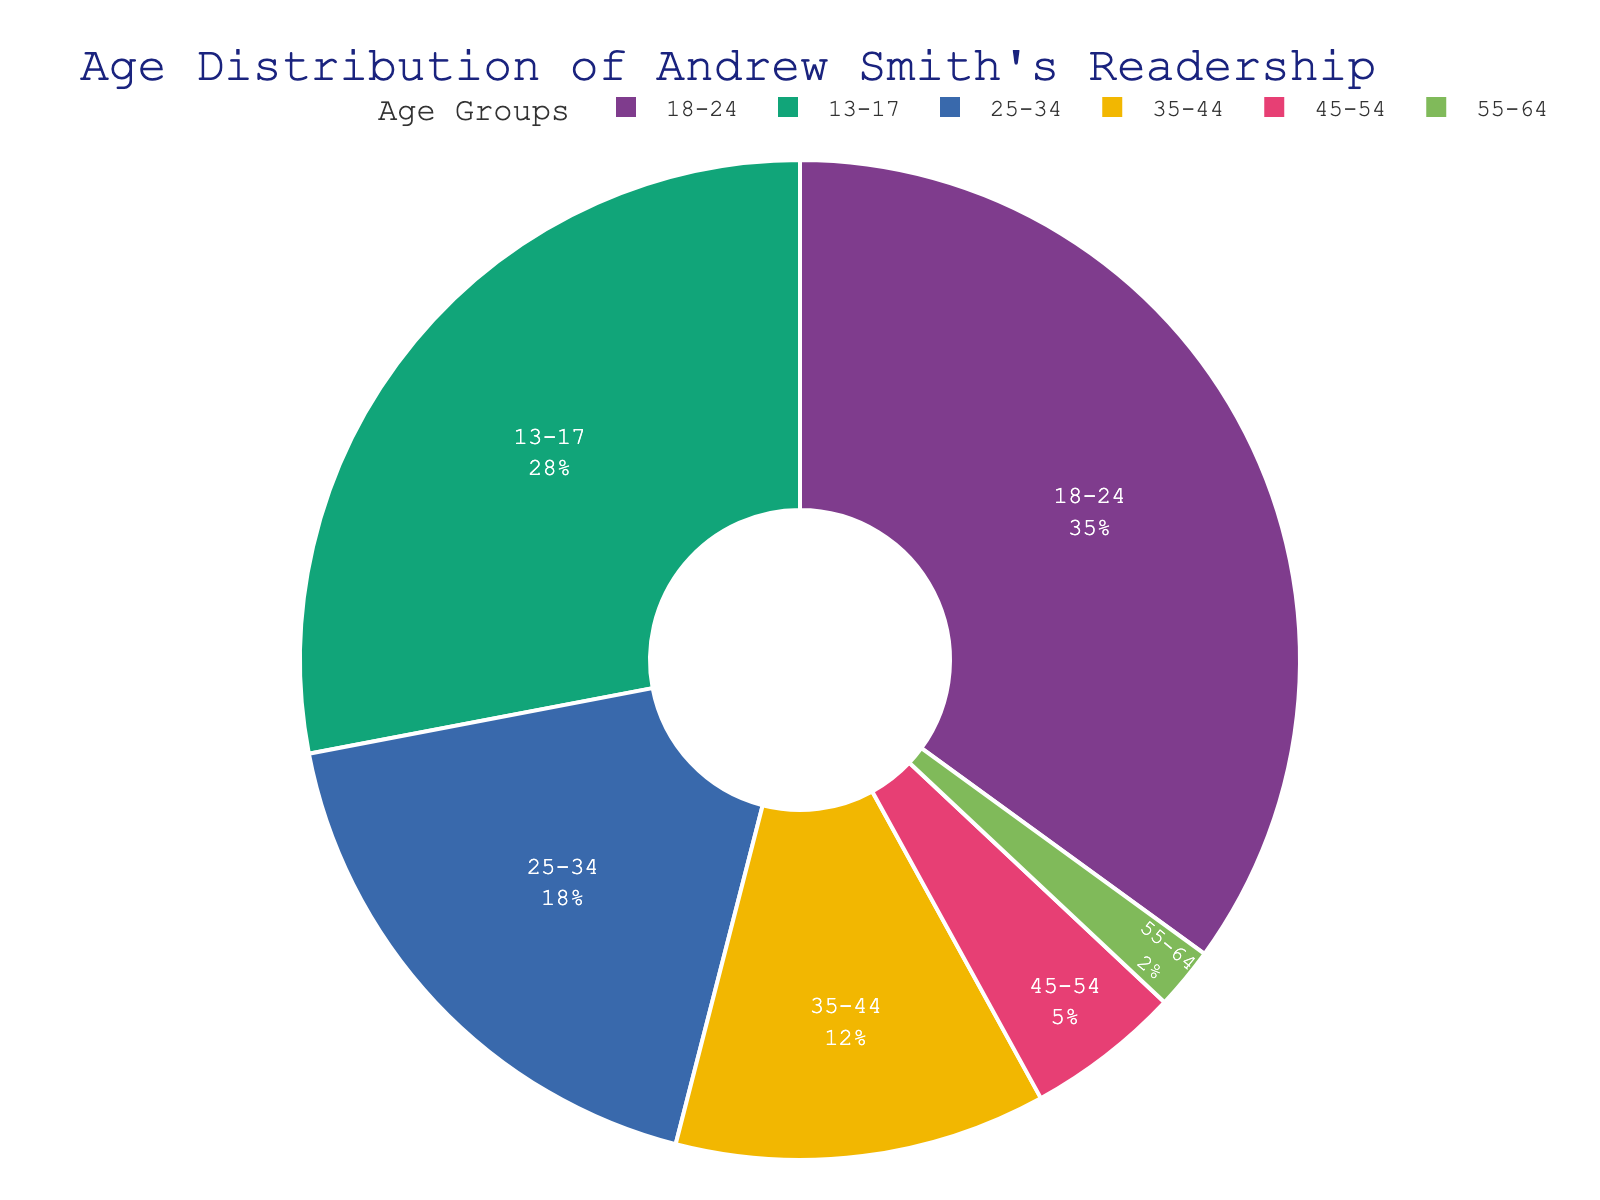Which age group has the highest percentage in Andrew Smith's readership? To determine the age group with the highest percentage, look at the section of the pie chart with the largest area or percentage label.
Answer: 18-24 What is the combined percentage of readers aged 35-44 and 45-54? Add the percentages of the two age groups: 12% (35-44) + 5% (45-54) = 17%.
Answer: 17% How does the proportion of readers aged 13-17 compare to those aged 25-34? Compare their percentages directly: 13-17 has 28% and 25-34 has 18%. 28% is greater than 18%.
Answer: 28% > 18% What is the difference in percentage between the 18-24 age group and the 55-64 age group? Subtract the percentage of the 55-64 group from the 18-24 group: 35% - 2% = 33%.
Answer: 33% Which age groups have a percentage less than 10%? Identify the age groups with percentages below 10%: 45-54 (5%) and 55-64 (2%).
Answer: 45-54, 55-64 What percentage of readers are aged 25-34 or older? Sum the percentages of all age groups from 25-34 to 55-64: 18% + 12% + 5% + 2% = 37%.
Answer: 37% If the total readership is 10,000 people, how many readers are aged 13-17? Calculate the number of readers by multiplying the total readership by the percentage of 13-17: 10,000 * 0.28 = 2,800.
Answer: 2,800 What is the difference in percentage points between the highest and the lowest age group proportions? Identify the highest percentage (18-24, 35%) and the lowest (55-64, 2%), then subtract: 35% - 2% = 33%.
Answer: 33% Is there an age group with a proportion close to the average of all groups? Find the average percentage first: (28% + 35% + 18% + 12% + 5% + 2%) / 6 = 16.67%. The 25-34 age group (18%) is closest to this average.
Answer: 25-34 